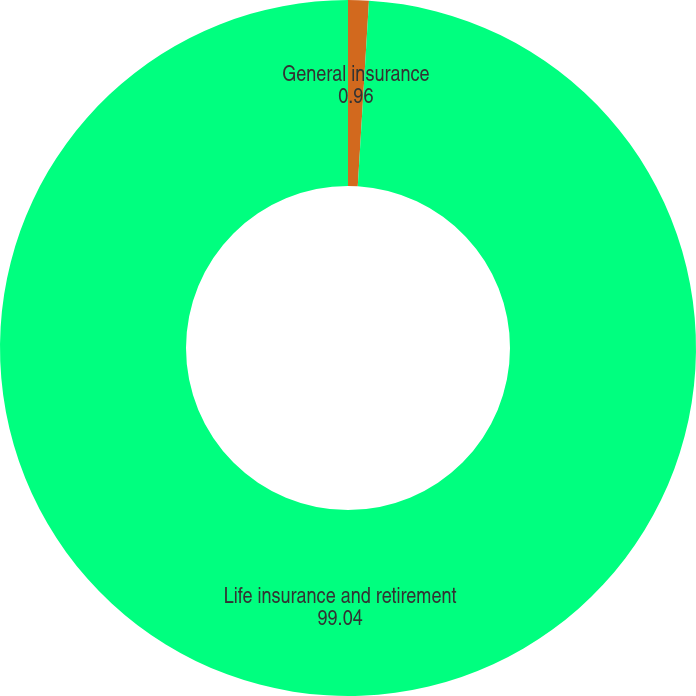Convert chart. <chart><loc_0><loc_0><loc_500><loc_500><pie_chart><fcel>General insurance<fcel>Life insurance and retirement<nl><fcel>0.96%<fcel>99.04%<nl></chart> 